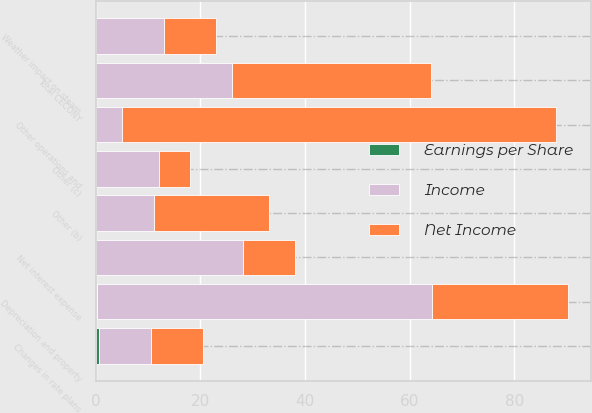Convert chart. <chart><loc_0><loc_0><loc_500><loc_500><stacked_bar_chart><ecel><fcel>Changes in rate plans<fcel>Weather impact on steam<fcel>Other operations and<fcel>Depreciation and property<fcel>Net interest expense<fcel>Other (b)<fcel>Total CECONY<fcel>Other (c)<nl><fcel>Earnings per Share<fcel>0.51<fcel>0.04<fcel>0.02<fcel>0.22<fcel>0.1<fcel>0.04<fcel>0.09<fcel>0.03<nl><fcel>Income<fcel>10<fcel>13<fcel>5<fcel>64<fcel>28<fcel>11<fcel>26<fcel>12<nl><fcel>Net Income<fcel>10<fcel>10<fcel>83<fcel>26<fcel>10<fcel>22<fcel>38<fcel>6<nl></chart> 